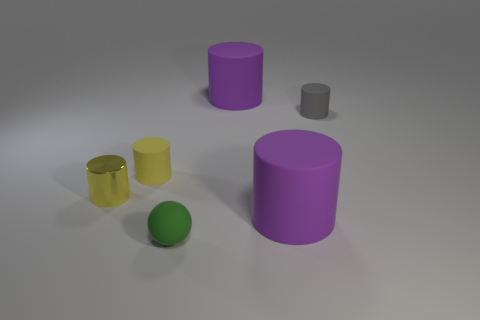The green object that is to the right of the yellow matte cylinder that is in front of the small gray rubber cylinder is what shape?
Provide a succinct answer. Sphere. What is the shape of the small green object that is made of the same material as the tiny gray cylinder?
Your answer should be compact. Sphere. What size is the yellow thing that is on the right side of the shiny thing that is behind the green ball?
Ensure brevity in your answer.  Small. The tiny yellow rubber object has what shape?
Offer a terse response. Cylinder. How many large things are either gray rubber cylinders or yellow rubber objects?
Make the answer very short. 0. What is the size of the yellow metallic object that is the same shape as the gray thing?
Your response must be concise. Small. How many rubber things are both behind the small yellow metal object and in front of the yellow metal cylinder?
Your response must be concise. 0. Is the shape of the gray thing the same as the matte thing that is to the left of the matte ball?
Ensure brevity in your answer.  Yes. Are there more objects behind the small yellow metallic cylinder than red spheres?
Your answer should be very brief. Yes. Are there fewer things behind the green rubber ball than tiny rubber cylinders?
Ensure brevity in your answer.  No. 